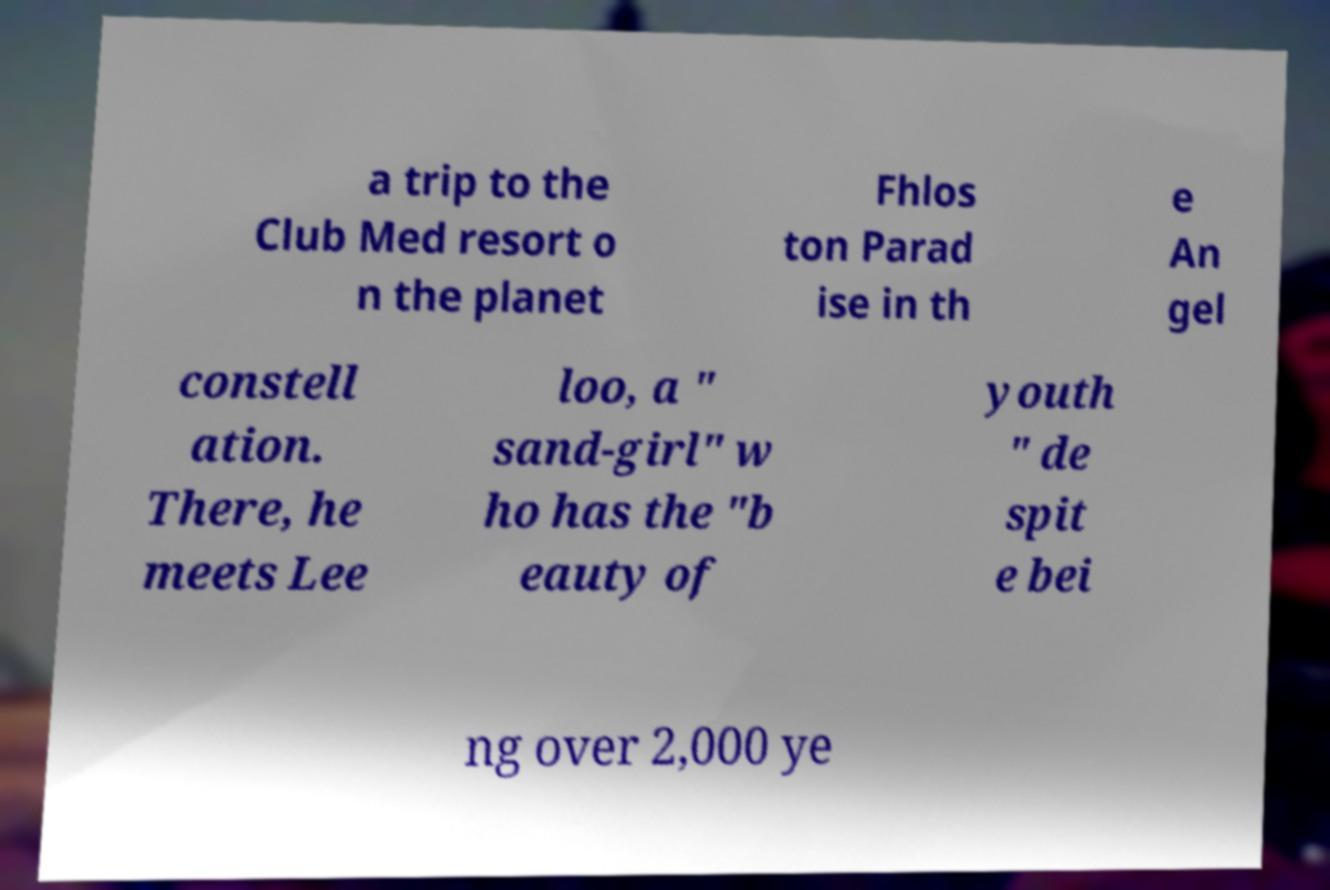Could you extract and type out the text from this image? a trip to the Club Med resort o n the planet Fhlos ton Parad ise in th e An gel constell ation. There, he meets Lee loo, a " sand-girl" w ho has the "b eauty of youth " de spit e bei ng over 2,000 ye 